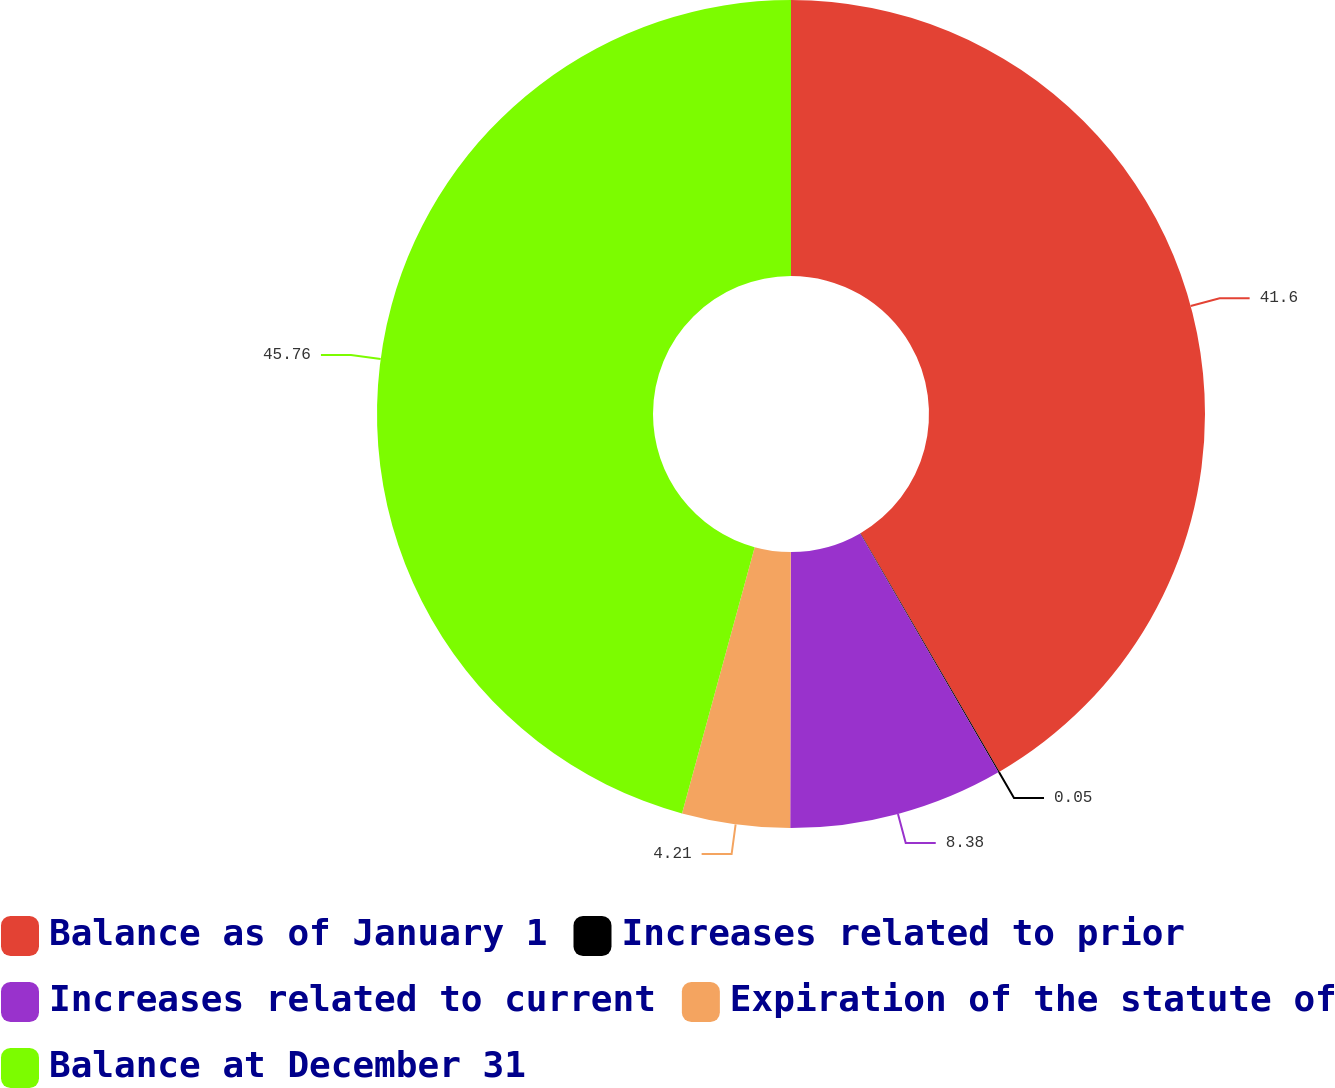Convert chart. <chart><loc_0><loc_0><loc_500><loc_500><pie_chart><fcel>Balance as of January 1<fcel>Increases related to prior<fcel>Increases related to current<fcel>Expiration of the statute of<fcel>Balance at December 31<nl><fcel>41.6%<fcel>0.05%<fcel>8.38%<fcel>4.21%<fcel>45.76%<nl></chart> 